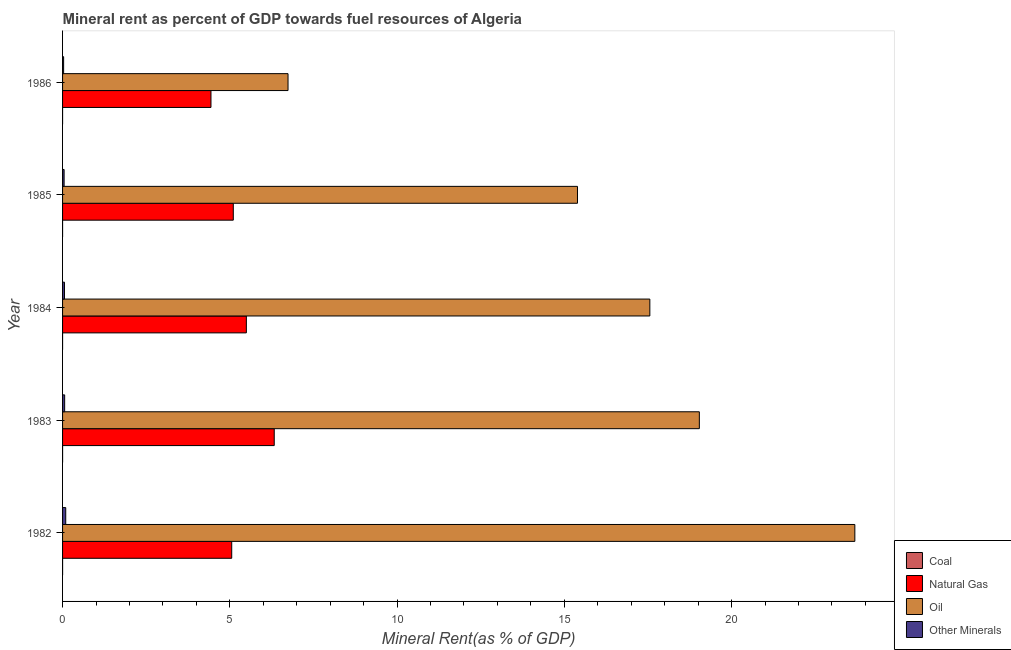How many different coloured bars are there?
Offer a terse response. 4. Are the number of bars on each tick of the Y-axis equal?
Provide a succinct answer. Yes. In how many cases, is the number of bars for a given year not equal to the number of legend labels?
Your response must be concise. 0. What is the  rent of other minerals in 1984?
Provide a succinct answer. 0.06. Across all years, what is the maximum  rent of other minerals?
Give a very brief answer. 0.09. Across all years, what is the minimum coal rent?
Provide a short and direct response. 1.11843058632871e-6. In which year was the natural gas rent maximum?
Your answer should be compact. 1983. What is the total coal rent in the graph?
Provide a succinct answer. 0. What is the difference between the natural gas rent in 1982 and that in 1983?
Provide a succinct answer. -1.27. What is the difference between the oil rent in 1985 and the  rent of other minerals in 1983?
Your answer should be very brief. 15.33. What is the average  rent of other minerals per year?
Provide a succinct answer. 0.06. In the year 1985, what is the difference between the natural gas rent and coal rent?
Your answer should be very brief. 5.1. What is the ratio of the coal rent in 1985 to that in 1986?
Provide a short and direct response. 96.59. Is the coal rent in 1983 less than that in 1985?
Give a very brief answer. No. Is the difference between the oil rent in 1983 and 1986 greater than the difference between the natural gas rent in 1983 and 1986?
Ensure brevity in your answer.  Yes. What is the difference between the highest and the second highest oil rent?
Give a very brief answer. 4.65. What is the difference between the highest and the lowest natural gas rent?
Your response must be concise. 1.89. In how many years, is the natural gas rent greater than the average natural gas rent taken over all years?
Ensure brevity in your answer.  2. What does the 3rd bar from the top in 1985 represents?
Offer a very short reply. Natural Gas. What does the 4th bar from the bottom in 1984 represents?
Make the answer very short. Other Minerals. Is it the case that in every year, the sum of the coal rent and natural gas rent is greater than the oil rent?
Make the answer very short. No. How many years are there in the graph?
Provide a short and direct response. 5. What is the difference between two consecutive major ticks on the X-axis?
Provide a succinct answer. 5. Are the values on the major ticks of X-axis written in scientific E-notation?
Ensure brevity in your answer.  No. Does the graph contain any zero values?
Offer a very short reply. No. Where does the legend appear in the graph?
Provide a short and direct response. Bottom right. How many legend labels are there?
Provide a succinct answer. 4. What is the title of the graph?
Provide a succinct answer. Mineral rent as percent of GDP towards fuel resources of Algeria. What is the label or title of the X-axis?
Make the answer very short. Mineral Rent(as % of GDP). What is the Mineral Rent(as % of GDP) in Coal in 1982?
Your answer should be compact. 0. What is the Mineral Rent(as % of GDP) of Natural Gas in 1982?
Your answer should be very brief. 5.06. What is the Mineral Rent(as % of GDP) of Oil in 1982?
Provide a succinct answer. 23.69. What is the Mineral Rent(as % of GDP) of Other Minerals in 1982?
Give a very brief answer. 0.09. What is the Mineral Rent(as % of GDP) in Coal in 1983?
Provide a short and direct response. 0. What is the Mineral Rent(as % of GDP) of Natural Gas in 1983?
Ensure brevity in your answer.  6.33. What is the Mineral Rent(as % of GDP) of Oil in 1983?
Give a very brief answer. 19.04. What is the Mineral Rent(as % of GDP) in Other Minerals in 1983?
Provide a short and direct response. 0.06. What is the Mineral Rent(as % of GDP) of Coal in 1984?
Keep it short and to the point. 6.52912655872695e-5. What is the Mineral Rent(as % of GDP) in Natural Gas in 1984?
Your answer should be very brief. 5.49. What is the Mineral Rent(as % of GDP) of Oil in 1984?
Your answer should be compact. 17.56. What is the Mineral Rent(as % of GDP) of Other Minerals in 1984?
Offer a terse response. 0.06. What is the Mineral Rent(as % of GDP) in Coal in 1985?
Make the answer very short. 0. What is the Mineral Rent(as % of GDP) of Natural Gas in 1985?
Your answer should be compact. 5.1. What is the Mineral Rent(as % of GDP) of Oil in 1985?
Offer a terse response. 15.39. What is the Mineral Rent(as % of GDP) of Other Minerals in 1985?
Provide a succinct answer. 0.05. What is the Mineral Rent(as % of GDP) of Coal in 1986?
Keep it short and to the point. 1.11843058632871e-6. What is the Mineral Rent(as % of GDP) in Natural Gas in 1986?
Keep it short and to the point. 4.44. What is the Mineral Rent(as % of GDP) in Oil in 1986?
Your response must be concise. 6.74. What is the Mineral Rent(as % of GDP) in Other Minerals in 1986?
Keep it short and to the point. 0.03. Across all years, what is the maximum Mineral Rent(as % of GDP) in Coal?
Give a very brief answer. 0. Across all years, what is the maximum Mineral Rent(as % of GDP) of Natural Gas?
Provide a succinct answer. 6.33. Across all years, what is the maximum Mineral Rent(as % of GDP) of Oil?
Provide a short and direct response. 23.69. Across all years, what is the maximum Mineral Rent(as % of GDP) in Other Minerals?
Provide a succinct answer. 0.09. Across all years, what is the minimum Mineral Rent(as % of GDP) of Coal?
Your answer should be compact. 1.11843058632871e-6. Across all years, what is the minimum Mineral Rent(as % of GDP) of Natural Gas?
Make the answer very short. 4.44. Across all years, what is the minimum Mineral Rent(as % of GDP) of Oil?
Provide a succinct answer. 6.74. Across all years, what is the minimum Mineral Rent(as % of GDP) of Other Minerals?
Your response must be concise. 0.03. What is the total Mineral Rent(as % of GDP) in Coal in the graph?
Offer a very short reply. 0. What is the total Mineral Rent(as % of GDP) of Natural Gas in the graph?
Your response must be concise. 26.42. What is the total Mineral Rent(as % of GDP) in Oil in the graph?
Make the answer very short. 82.41. What is the total Mineral Rent(as % of GDP) of Other Minerals in the graph?
Provide a succinct answer. 0.29. What is the difference between the Mineral Rent(as % of GDP) of Natural Gas in 1982 and that in 1983?
Keep it short and to the point. -1.27. What is the difference between the Mineral Rent(as % of GDP) in Oil in 1982 and that in 1983?
Your answer should be compact. 4.65. What is the difference between the Mineral Rent(as % of GDP) in Other Minerals in 1982 and that in 1983?
Offer a terse response. 0.03. What is the difference between the Mineral Rent(as % of GDP) of Coal in 1982 and that in 1984?
Your answer should be very brief. 0. What is the difference between the Mineral Rent(as % of GDP) of Natural Gas in 1982 and that in 1984?
Make the answer very short. -0.44. What is the difference between the Mineral Rent(as % of GDP) of Oil in 1982 and that in 1984?
Keep it short and to the point. 6.13. What is the difference between the Mineral Rent(as % of GDP) in Other Minerals in 1982 and that in 1984?
Your answer should be compact. 0.04. What is the difference between the Mineral Rent(as % of GDP) of Natural Gas in 1982 and that in 1985?
Keep it short and to the point. -0.05. What is the difference between the Mineral Rent(as % of GDP) in Oil in 1982 and that in 1985?
Provide a short and direct response. 8.29. What is the difference between the Mineral Rent(as % of GDP) in Other Minerals in 1982 and that in 1985?
Your answer should be very brief. 0.05. What is the difference between the Mineral Rent(as % of GDP) of Natural Gas in 1982 and that in 1986?
Provide a succinct answer. 0.62. What is the difference between the Mineral Rent(as % of GDP) of Oil in 1982 and that in 1986?
Give a very brief answer. 16.95. What is the difference between the Mineral Rent(as % of GDP) of Other Minerals in 1982 and that in 1986?
Provide a short and direct response. 0.06. What is the difference between the Mineral Rent(as % of GDP) of Natural Gas in 1983 and that in 1984?
Your response must be concise. 0.83. What is the difference between the Mineral Rent(as % of GDP) of Oil in 1983 and that in 1984?
Offer a terse response. 1.48. What is the difference between the Mineral Rent(as % of GDP) in Other Minerals in 1983 and that in 1984?
Ensure brevity in your answer.  0.01. What is the difference between the Mineral Rent(as % of GDP) in Coal in 1983 and that in 1985?
Offer a very short reply. 0. What is the difference between the Mineral Rent(as % of GDP) of Natural Gas in 1983 and that in 1985?
Your response must be concise. 1.22. What is the difference between the Mineral Rent(as % of GDP) of Oil in 1983 and that in 1985?
Provide a succinct answer. 3.64. What is the difference between the Mineral Rent(as % of GDP) in Other Minerals in 1983 and that in 1985?
Provide a short and direct response. 0.02. What is the difference between the Mineral Rent(as % of GDP) in Natural Gas in 1983 and that in 1986?
Offer a very short reply. 1.89. What is the difference between the Mineral Rent(as % of GDP) of Oil in 1983 and that in 1986?
Offer a terse response. 12.3. What is the difference between the Mineral Rent(as % of GDP) of Other Minerals in 1983 and that in 1986?
Offer a very short reply. 0.03. What is the difference between the Mineral Rent(as % of GDP) of Coal in 1984 and that in 1985?
Offer a terse response. -0. What is the difference between the Mineral Rent(as % of GDP) in Natural Gas in 1984 and that in 1985?
Offer a very short reply. 0.39. What is the difference between the Mineral Rent(as % of GDP) in Oil in 1984 and that in 1985?
Offer a terse response. 2.16. What is the difference between the Mineral Rent(as % of GDP) in Other Minerals in 1984 and that in 1985?
Offer a terse response. 0.01. What is the difference between the Mineral Rent(as % of GDP) of Coal in 1984 and that in 1986?
Provide a succinct answer. 0. What is the difference between the Mineral Rent(as % of GDP) of Natural Gas in 1984 and that in 1986?
Give a very brief answer. 1.06. What is the difference between the Mineral Rent(as % of GDP) in Oil in 1984 and that in 1986?
Provide a short and direct response. 10.82. What is the difference between the Mineral Rent(as % of GDP) of Other Minerals in 1984 and that in 1986?
Provide a short and direct response. 0.03. What is the difference between the Mineral Rent(as % of GDP) in Coal in 1985 and that in 1986?
Your response must be concise. 0. What is the difference between the Mineral Rent(as % of GDP) in Natural Gas in 1985 and that in 1986?
Offer a terse response. 0.67. What is the difference between the Mineral Rent(as % of GDP) in Oil in 1985 and that in 1986?
Make the answer very short. 8.65. What is the difference between the Mineral Rent(as % of GDP) in Other Minerals in 1985 and that in 1986?
Your response must be concise. 0.01. What is the difference between the Mineral Rent(as % of GDP) of Coal in 1982 and the Mineral Rent(as % of GDP) of Natural Gas in 1983?
Make the answer very short. -6.33. What is the difference between the Mineral Rent(as % of GDP) in Coal in 1982 and the Mineral Rent(as % of GDP) in Oil in 1983?
Keep it short and to the point. -19.04. What is the difference between the Mineral Rent(as % of GDP) in Coal in 1982 and the Mineral Rent(as % of GDP) in Other Minerals in 1983?
Ensure brevity in your answer.  -0.06. What is the difference between the Mineral Rent(as % of GDP) in Natural Gas in 1982 and the Mineral Rent(as % of GDP) in Oil in 1983?
Provide a succinct answer. -13.98. What is the difference between the Mineral Rent(as % of GDP) of Natural Gas in 1982 and the Mineral Rent(as % of GDP) of Other Minerals in 1983?
Your answer should be very brief. 4.99. What is the difference between the Mineral Rent(as % of GDP) in Oil in 1982 and the Mineral Rent(as % of GDP) in Other Minerals in 1983?
Your answer should be very brief. 23.62. What is the difference between the Mineral Rent(as % of GDP) in Coal in 1982 and the Mineral Rent(as % of GDP) in Natural Gas in 1984?
Your response must be concise. -5.49. What is the difference between the Mineral Rent(as % of GDP) of Coal in 1982 and the Mineral Rent(as % of GDP) of Oil in 1984?
Your answer should be very brief. -17.56. What is the difference between the Mineral Rent(as % of GDP) of Coal in 1982 and the Mineral Rent(as % of GDP) of Other Minerals in 1984?
Your response must be concise. -0.06. What is the difference between the Mineral Rent(as % of GDP) in Natural Gas in 1982 and the Mineral Rent(as % of GDP) in Other Minerals in 1984?
Ensure brevity in your answer.  5. What is the difference between the Mineral Rent(as % of GDP) of Oil in 1982 and the Mineral Rent(as % of GDP) of Other Minerals in 1984?
Provide a short and direct response. 23.63. What is the difference between the Mineral Rent(as % of GDP) of Coal in 1982 and the Mineral Rent(as % of GDP) of Natural Gas in 1985?
Give a very brief answer. -5.1. What is the difference between the Mineral Rent(as % of GDP) of Coal in 1982 and the Mineral Rent(as % of GDP) of Oil in 1985?
Make the answer very short. -15.39. What is the difference between the Mineral Rent(as % of GDP) of Coal in 1982 and the Mineral Rent(as % of GDP) of Other Minerals in 1985?
Ensure brevity in your answer.  -0.05. What is the difference between the Mineral Rent(as % of GDP) in Natural Gas in 1982 and the Mineral Rent(as % of GDP) in Oil in 1985?
Give a very brief answer. -10.34. What is the difference between the Mineral Rent(as % of GDP) in Natural Gas in 1982 and the Mineral Rent(as % of GDP) in Other Minerals in 1985?
Give a very brief answer. 5.01. What is the difference between the Mineral Rent(as % of GDP) in Oil in 1982 and the Mineral Rent(as % of GDP) in Other Minerals in 1985?
Keep it short and to the point. 23.64. What is the difference between the Mineral Rent(as % of GDP) of Coal in 1982 and the Mineral Rent(as % of GDP) of Natural Gas in 1986?
Keep it short and to the point. -4.44. What is the difference between the Mineral Rent(as % of GDP) of Coal in 1982 and the Mineral Rent(as % of GDP) of Oil in 1986?
Provide a short and direct response. -6.74. What is the difference between the Mineral Rent(as % of GDP) in Coal in 1982 and the Mineral Rent(as % of GDP) in Other Minerals in 1986?
Make the answer very short. -0.03. What is the difference between the Mineral Rent(as % of GDP) of Natural Gas in 1982 and the Mineral Rent(as % of GDP) of Oil in 1986?
Your answer should be compact. -1.68. What is the difference between the Mineral Rent(as % of GDP) in Natural Gas in 1982 and the Mineral Rent(as % of GDP) in Other Minerals in 1986?
Offer a terse response. 5.03. What is the difference between the Mineral Rent(as % of GDP) of Oil in 1982 and the Mineral Rent(as % of GDP) of Other Minerals in 1986?
Ensure brevity in your answer.  23.65. What is the difference between the Mineral Rent(as % of GDP) in Coal in 1983 and the Mineral Rent(as % of GDP) in Natural Gas in 1984?
Make the answer very short. -5.49. What is the difference between the Mineral Rent(as % of GDP) of Coal in 1983 and the Mineral Rent(as % of GDP) of Oil in 1984?
Provide a succinct answer. -17.56. What is the difference between the Mineral Rent(as % of GDP) of Coal in 1983 and the Mineral Rent(as % of GDP) of Other Minerals in 1984?
Your answer should be very brief. -0.06. What is the difference between the Mineral Rent(as % of GDP) in Natural Gas in 1983 and the Mineral Rent(as % of GDP) in Oil in 1984?
Give a very brief answer. -11.23. What is the difference between the Mineral Rent(as % of GDP) in Natural Gas in 1983 and the Mineral Rent(as % of GDP) in Other Minerals in 1984?
Offer a terse response. 6.27. What is the difference between the Mineral Rent(as % of GDP) in Oil in 1983 and the Mineral Rent(as % of GDP) in Other Minerals in 1984?
Offer a terse response. 18.98. What is the difference between the Mineral Rent(as % of GDP) of Coal in 1983 and the Mineral Rent(as % of GDP) of Natural Gas in 1985?
Make the answer very short. -5.1. What is the difference between the Mineral Rent(as % of GDP) in Coal in 1983 and the Mineral Rent(as % of GDP) in Oil in 1985?
Offer a terse response. -15.39. What is the difference between the Mineral Rent(as % of GDP) of Coal in 1983 and the Mineral Rent(as % of GDP) of Other Minerals in 1985?
Give a very brief answer. -0.05. What is the difference between the Mineral Rent(as % of GDP) in Natural Gas in 1983 and the Mineral Rent(as % of GDP) in Oil in 1985?
Your response must be concise. -9.07. What is the difference between the Mineral Rent(as % of GDP) in Natural Gas in 1983 and the Mineral Rent(as % of GDP) in Other Minerals in 1985?
Give a very brief answer. 6.28. What is the difference between the Mineral Rent(as % of GDP) of Oil in 1983 and the Mineral Rent(as % of GDP) of Other Minerals in 1985?
Provide a short and direct response. 18.99. What is the difference between the Mineral Rent(as % of GDP) in Coal in 1983 and the Mineral Rent(as % of GDP) in Natural Gas in 1986?
Provide a succinct answer. -4.44. What is the difference between the Mineral Rent(as % of GDP) in Coal in 1983 and the Mineral Rent(as % of GDP) in Oil in 1986?
Offer a terse response. -6.74. What is the difference between the Mineral Rent(as % of GDP) in Coal in 1983 and the Mineral Rent(as % of GDP) in Other Minerals in 1986?
Ensure brevity in your answer.  -0.03. What is the difference between the Mineral Rent(as % of GDP) of Natural Gas in 1983 and the Mineral Rent(as % of GDP) of Oil in 1986?
Make the answer very short. -0.41. What is the difference between the Mineral Rent(as % of GDP) of Natural Gas in 1983 and the Mineral Rent(as % of GDP) of Other Minerals in 1986?
Ensure brevity in your answer.  6.3. What is the difference between the Mineral Rent(as % of GDP) in Oil in 1983 and the Mineral Rent(as % of GDP) in Other Minerals in 1986?
Provide a short and direct response. 19.01. What is the difference between the Mineral Rent(as % of GDP) in Coal in 1984 and the Mineral Rent(as % of GDP) in Natural Gas in 1985?
Your response must be concise. -5.1. What is the difference between the Mineral Rent(as % of GDP) of Coal in 1984 and the Mineral Rent(as % of GDP) of Oil in 1985?
Offer a very short reply. -15.39. What is the difference between the Mineral Rent(as % of GDP) of Coal in 1984 and the Mineral Rent(as % of GDP) of Other Minerals in 1985?
Ensure brevity in your answer.  -0.05. What is the difference between the Mineral Rent(as % of GDP) in Natural Gas in 1984 and the Mineral Rent(as % of GDP) in Oil in 1985?
Ensure brevity in your answer.  -9.9. What is the difference between the Mineral Rent(as % of GDP) in Natural Gas in 1984 and the Mineral Rent(as % of GDP) in Other Minerals in 1985?
Ensure brevity in your answer.  5.45. What is the difference between the Mineral Rent(as % of GDP) in Oil in 1984 and the Mineral Rent(as % of GDP) in Other Minerals in 1985?
Offer a terse response. 17.51. What is the difference between the Mineral Rent(as % of GDP) of Coal in 1984 and the Mineral Rent(as % of GDP) of Natural Gas in 1986?
Make the answer very short. -4.44. What is the difference between the Mineral Rent(as % of GDP) in Coal in 1984 and the Mineral Rent(as % of GDP) in Oil in 1986?
Provide a succinct answer. -6.74. What is the difference between the Mineral Rent(as % of GDP) of Coal in 1984 and the Mineral Rent(as % of GDP) of Other Minerals in 1986?
Provide a succinct answer. -0.03. What is the difference between the Mineral Rent(as % of GDP) in Natural Gas in 1984 and the Mineral Rent(as % of GDP) in Oil in 1986?
Offer a terse response. -1.25. What is the difference between the Mineral Rent(as % of GDP) of Natural Gas in 1984 and the Mineral Rent(as % of GDP) of Other Minerals in 1986?
Provide a short and direct response. 5.46. What is the difference between the Mineral Rent(as % of GDP) in Oil in 1984 and the Mineral Rent(as % of GDP) in Other Minerals in 1986?
Offer a very short reply. 17.53. What is the difference between the Mineral Rent(as % of GDP) of Coal in 1985 and the Mineral Rent(as % of GDP) of Natural Gas in 1986?
Make the answer very short. -4.44. What is the difference between the Mineral Rent(as % of GDP) of Coal in 1985 and the Mineral Rent(as % of GDP) of Oil in 1986?
Provide a succinct answer. -6.74. What is the difference between the Mineral Rent(as % of GDP) in Coal in 1985 and the Mineral Rent(as % of GDP) in Other Minerals in 1986?
Offer a terse response. -0.03. What is the difference between the Mineral Rent(as % of GDP) of Natural Gas in 1985 and the Mineral Rent(as % of GDP) of Oil in 1986?
Provide a short and direct response. -1.64. What is the difference between the Mineral Rent(as % of GDP) in Natural Gas in 1985 and the Mineral Rent(as % of GDP) in Other Minerals in 1986?
Ensure brevity in your answer.  5.07. What is the difference between the Mineral Rent(as % of GDP) in Oil in 1985 and the Mineral Rent(as % of GDP) in Other Minerals in 1986?
Keep it short and to the point. 15.36. What is the average Mineral Rent(as % of GDP) of Coal per year?
Make the answer very short. 0. What is the average Mineral Rent(as % of GDP) in Natural Gas per year?
Offer a terse response. 5.28. What is the average Mineral Rent(as % of GDP) in Oil per year?
Keep it short and to the point. 16.48. What is the average Mineral Rent(as % of GDP) in Other Minerals per year?
Offer a very short reply. 0.06. In the year 1982, what is the difference between the Mineral Rent(as % of GDP) in Coal and Mineral Rent(as % of GDP) in Natural Gas?
Your response must be concise. -5.06. In the year 1982, what is the difference between the Mineral Rent(as % of GDP) in Coal and Mineral Rent(as % of GDP) in Oil?
Provide a succinct answer. -23.69. In the year 1982, what is the difference between the Mineral Rent(as % of GDP) of Coal and Mineral Rent(as % of GDP) of Other Minerals?
Your response must be concise. -0.09. In the year 1982, what is the difference between the Mineral Rent(as % of GDP) of Natural Gas and Mineral Rent(as % of GDP) of Oil?
Ensure brevity in your answer.  -18.63. In the year 1982, what is the difference between the Mineral Rent(as % of GDP) in Natural Gas and Mineral Rent(as % of GDP) in Other Minerals?
Your answer should be compact. 4.96. In the year 1982, what is the difference between the Mineral Rent(as % of GDP) in Oil and Mineral Rent(as % of GDP) in Other Minerals?
Keep it short and to the point. 23.59. In the year 1983, what is the difference between the Mineral Rent(as % of GDP) of Coal and Mineral Rent(as % of GDP) of Natural Gas?
Your answer should be compact. -6.33. In the year 1983, what is the difference between the Mineral Rent(as % of GDP) in Coal and Mineral Rent(as % of GDP) in Oil?
Offer a terse response. -19.04. In the year 1983, what is the difference between the Mineral Rent(as % of GDP) in Coal and Mineral Rent(as % of GDP) in Other Minerals?
Make the answer very short. -0.06. In the year 1983, what is the difference between the Mineral Rent(as % of GDP) of Natural Gas and Mineral Rent(as % of GDP) of Oil?
Your response must be concise. -12.71. In the year 1983, what is the difference between the Mineral Rent(as % of GDP) in Natural Gas and Mineral Rent(as % of GDP) in Other Minerals?
Your response must be concise. 6.27. In the year 1983, what is the difference between the Mineral Rent(as % of GDP) of Oil and Mineral Rent(as % of GDP) of Other Minerals?
Provide a short and direct response. 18.97. In the year 1984, what is the difference between the Mineral Rent(as % of GDP) in Coal and Mineral Rent(as % of GDP) in Natural Gas?
Provide a succinct answer. -5.49. In the year 1984, what is the difference between the Mineral Rent(as % of GDP) in Coal and Mineral Rent(as % of GDP) in Oil?
Provide a succinct answer. -17.56. In the year 1984, what is the difference between the Mineral Rent(as % of GDP) of Coal and Mineral Rent(as % of GDP) of Other Minerals?
Give a very brief answer. -0.06. In the year 1984, what is the difference between the Mineral Rent(as % of GDP) in Natural Gas and Mineral Rent(as % of GDP) in Oil?
Offer a very short reply. -12.06. In the year 1984, what is the difference between the Mineral Rent(as % of GDP) in Natural Gas and Mineral Rent(as % of GDP) in Other Minerals?
Provide a succinct answer. 5.44. In the year 1984, what is the difference between the Mineral Rent(as % of GDP) of Oil and Mineral Rent(as % of GDP) of Other Minerals?
Your response must be concise. 17.5. In the year 1985, what is the difference between the Mineral Rent(as % of GDP) of Coal and Mineral Rent(as % of GDP) of Natural Gas?
Offer a very short reply. -5.1. In the year 1985, what is the difference between the Mineral Rent(as % of GDP) of Coal and Mineral Rent(as % of GDP) of Oil?
Your response must be concise. -15.39. In the year 1985, what is the difference between the Mineral Rent(as % of GDP) in Coal and Mineral Rent(as % of GDP) in Other Minerals?
Your response must be concise. -0.05. In the year 1985, what is the difference between the Mineral Rent(as % of GDP) in Natural Gas and Mineral Rent(as % of GDP) in Oil?
Offer a very short reply. -10.29. In the year 1985, what is the difference between the Mineral Rent(as % of GDP) in Natural Gas and Mineral Rent(as % of GDP) in Other Minerals?
Your answer should be compact. 5.06. In the year 1985, what is the difference between the Mineral Rent(as % of GDP) of Oil and Mineral Rent(as % of GDP) of Other Minerals?
Provide a succinct answer. 15.35. In the year 1986, what is the difference between the Mineral Rent(as % of GDP) of Coal and Mineral Rent(as % of GDP) of Natural Gas?
Keep it short and to the point. -4.44. In the year 1986, what is the difference between the Mineral Rent(as % of GDP) of Coal and Mineral Rent(as % of GDP) of Oil?
Provide a short and direct response. -6.74. In the year 1986, what is the difference between the Mineral Rent(as % of GDP) in Coal and Mineral Rent(as % of GDP) in Other Minerals?
Give a very brief answer. -0.03. In the year 1986, what is the difference between the Mineral Rent(as % of GDP) in Natural Gas and Mineral Rent(as % of GDP) in Oil?
Give a very brief answer. -2.3. In the year 1986, what is the difference between the Mineral Rent(as % of GDP) in Natural Gas and Mineral Rent(as % of GDP) in Other Minerals?
Ensure brevity in your answer.  4.4. In the year 1986, what is the difference between the Mineral Rent(as % of GDP) in Oil and Mineral Rent(as % of GDP) in Other Minerals?
Keep it short and to the point. 6.71. What is the ratio of the Mineral Rent(as % of GDP) in Coal in 1982 to that in 1983?
Offer a very short reply. 2.81. What is the ratio of the Mineral Rent(as % of GDP) in Natural Gas in 1982 to that in 1983?
Give a very brief answer. 0.8. What is the ratio of the Mineral Rent(as % of GDP) in Oil in 1982 to that in 1983?
Keep it short and to the point. 1.24. What is the ratio of the Mineral Rent(as % of GDP) in Other Minerals in 1982 to that in 1983?
Offer a very short reply. 1.52. What is the ratio of the Mineral Rent(as % of GDP) of Coal in 1982 to that in 1984?
Your answer should be compact. 6.15. What is the ratio of the Mineral Rent(as % of GDP) in Natural Gas in 1982 to that in 1984?
Ensure brevity in your answer.  0.92. What is the ratio of the Mineral Rent(as % of GDP) of Oil in 1982 to that in 1984?
Your response must be concise. 1.35. What is the ratio of the Mineral Rent(as % of GDP) of Other Minerals in 1982 to that in 1984?
Provide a short and direct response. 1.66. What is the ratio of the Mineral Rent(as % of GDP) in Coal in 1982 to that in 1985?
Offer a very short reply. 3.72. What is the ratio of the Mineral Rent(as % of GDP) of Oil in 1982 to that in 1985?
Give a very brief answer. 1.54. What is the ratio of the Mineral Rent(as % of GDP) of Other Minerals in 1982 to that in 1985?
Give a very brief answer. 2.06. What is the ratio of the Mineral Rent(as % of GDP) in Coal in 1982 to that in 1986?
Give a very brief answer. 359.19. What is the ratio of the Mineral Rent(as % of GDP) in Natural Gas in 1982 to that in 1986?
Keep it short and to the point. 1.14. What is the ratio of the Mineral Rent(as % of GDP) in Oil in 1982 to that in 1986?
Your answer should be compact. 3.51. What is the ratio of the Mineral Rent(as % of GDP) of Other Minerals in 1982 to that in 1986?
Ensure brevity in your answer.  2.99. What is the ratio of the Mineral Rent(as % of GDP) in Coal in 1983 to that in 1984?
Provide a short and direct response. 2.19. What is the ratio of the Mineral Rent(as % of GDP) in Natural Gas in 1983 to that in 1984?
Offer a terse response. 1.15. What is the ratio of the Mineral Rent(as % of GDP) in Oil in 1983 to that in 1984?
Give a very brief answer. 1.08. What is the ratio of the Mineral Rent(as % of GDP) of Other Minerals in 1983 to that in 1984?
Keep it short and to the point. 1.09. What is the ratio of the Mineral Rent(as % of GDP) of Coal in 1983 to that in 1985?
Make the answer very short. 1.32. What is the ratio of the Mineral Rent(as % of GDP) of Natural Gas in 1983 to that in 1985?
Offer a very short reply. 1.24. What is the ratio of the Mineral Rent(as % of GDP) of Oil in 1983 to that in 1985?
Your response must be concise. 1.24. What is the ratio of the Mineral Rent(as % of GDP) of Other Minerals in 1983 to that in 1985?
Give a very brief answer. 1.36. What is the ratio of the Mineral Rent(as % of GDP) of Coal in 1983 to that in 1986?
Provide a succinct answer. 127.94. What is the ratio of the Mineral Rent(as % of GDP) in Natural Gas in 1983 to that in 1986?
Provide a succinct answer. 1.43. What is the ratio of the Mineral Rent(as % of GDP) of Oil in 1983 to that in 1986?
Offer a very short reply. 2.82. What is the ratio of the Mineral Rent(as % of GDP) in Other Minerals in 1983 to that in 1986?
Your answer should be very brief. 1.97. What is the ratio of the Mineral Rent(as % of GDP) of Coal in 1984 to that in 1985?
Make the answer very short. 0.6. What is the ratio of the Mineral Rent(as % of GDP) of Natural Gas in 1984 to that in 1985?
Provide a short and direct response. 1.08. What is the ratio of the Mineral Rent(as % of GDP) in Oil in 1984 to that in 1985?
Give a very brief answer. 1.14. What is the ratio of the Mineral Rent(as % of GDP) of Other Minerals in 1984 to that in 1985?
Keep it short and to the point. 1.24. What is the ratio of the Mineral Rent(as % of GDP) in Coal in 1984 to that in 1986?
Offer a terse response. 58.38. What is the ratio of the Mineral Rent(as % of GDP) in Natural Gas in 1984 to that in 1986?
Give a very brief answer. 1.24. What is the ratio of the Mineral Rent(as % of GDP) of Oil in 1984 to that in 1986?
Offer a terse response. 2.6. What is the ratio of the Mineral Rent(as % of GDP) of Other Minerals in 1984 to that in 1986?
Offer a terse response. 1.8. What is the ratio of the Mineral Rent(as % of GDP) in Coal in 1985 to that in 1986?
Ensure brevity in your answer.  96.59. What is the ratio of the Mineral Rent(as % of GDP) of Natural Gas in 1985 to that in 1986?
Your answer should be very brief. 1.15. What is the ratio of the Mineral Rent(as % of GDP) in Oil in 1985 to that in 1986?
Offer a terse response. 2.28. What is the ratio of the Mineral Rent(as % of GDP) in Other Minerals in 1985 to that in 1986?
Offer a very short reply. 1.45. What is the difference between the highest and the second highest Mineral Rent(as % of GDP) in Coal?
Give a very brief answer. 0. What is the difference between the highest and the second highest Mineral Rent(as % of GDP) in Natural Gas?
Ensure brevity in your answer.  0.83. What is the difference between the highest and the second highest Mineral Rent(as % of GDP) of Oil?
Provide a succinct answer. 4.65. What is the difference between the highest and the second highest Mineral Rent(as % of GDP) of Other Minerals?
Your response must be concise. 0.03. What is the difference between the highest and the lowest Mineral Rent(as % of GDP) of Coal?
Your answer should be compact. 0. What is the difference between the highest and the lowest Mineral Rent(as % of GDP) of Natural Gas?
Make the answer very short. 1.89. What is the difference between the highest and the lowest Mineral Rent(as % of GDP) of Oil?
Your answer should be compact. 16.95. What is the difference between the highest and the lowest Mineral Rent(as % of GDP) in Other Minerals?
Your answer should be compact. 0.06. 